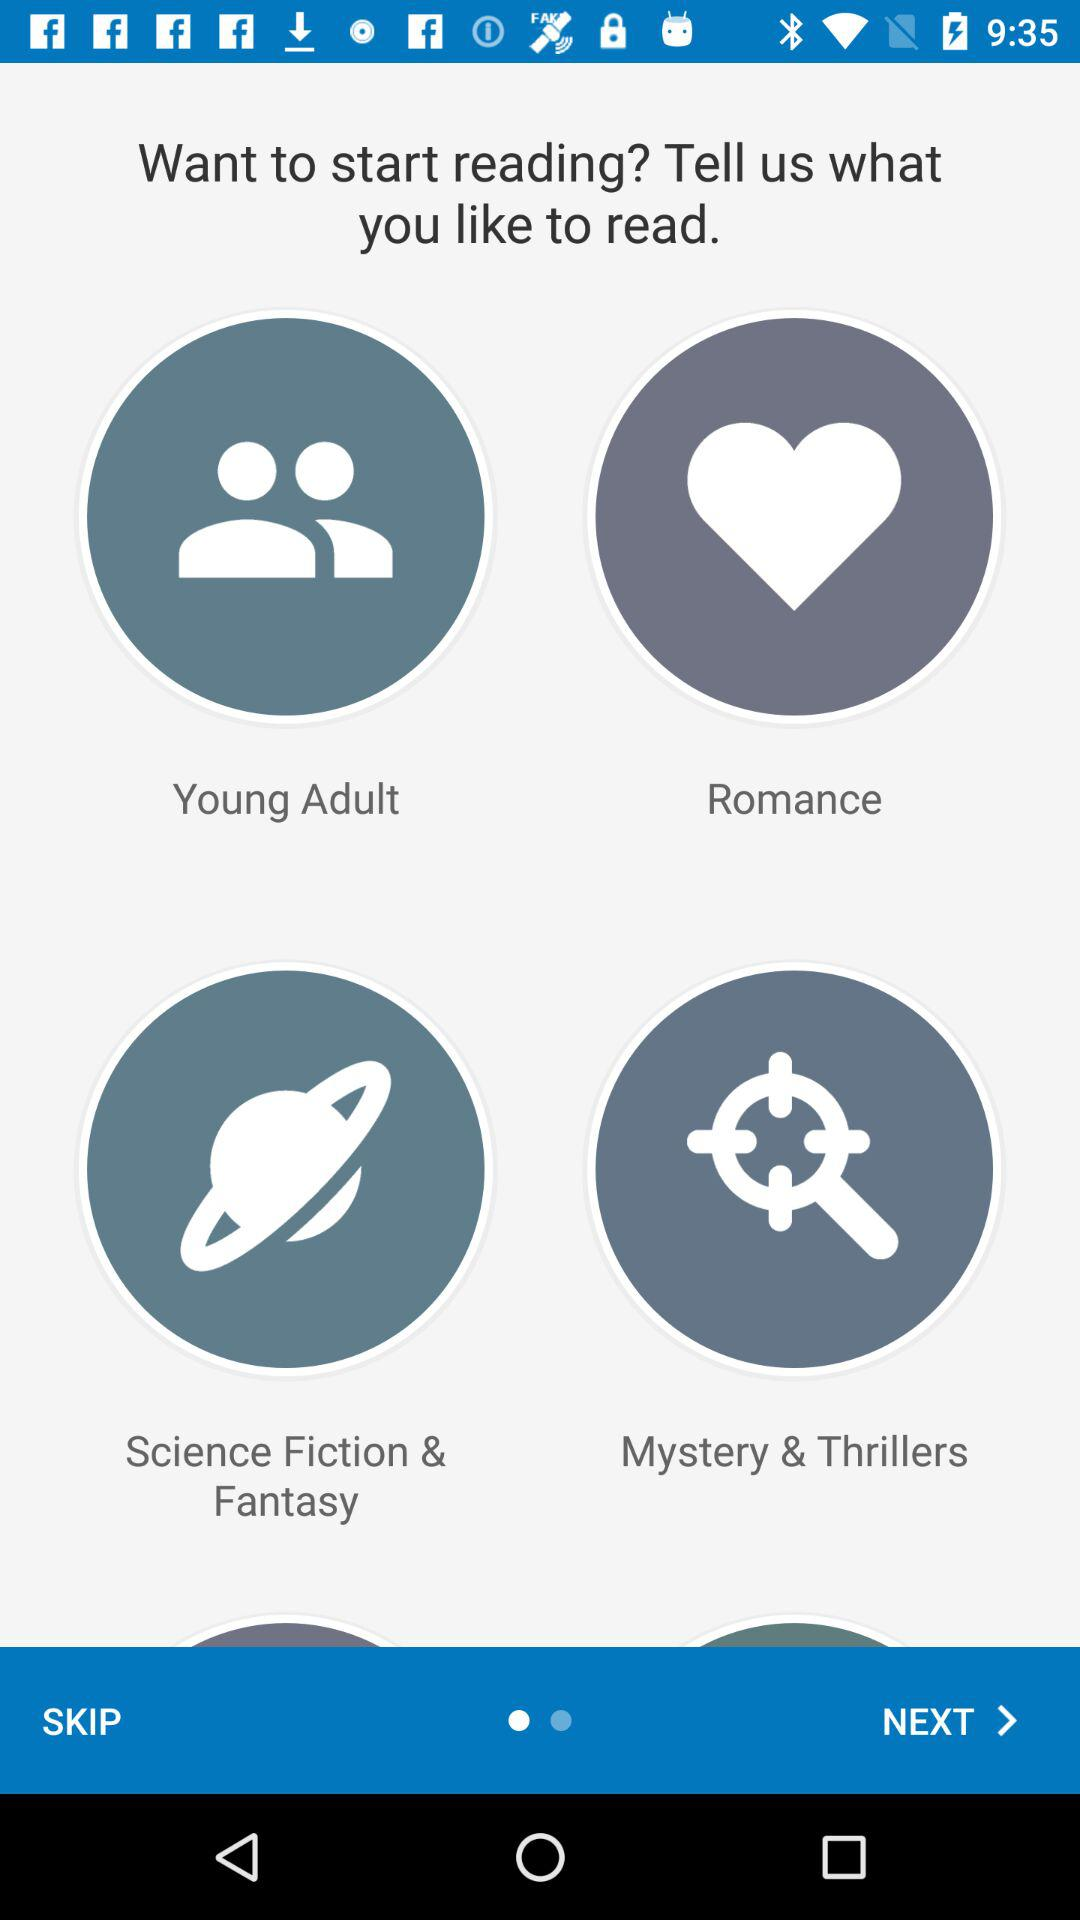How can we share content?
When the provided information is insufficient, respond with <no answer>. <no answer> 